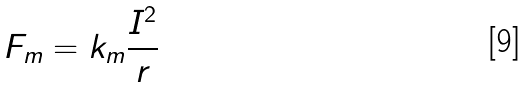Convert formula to latex. <formula><loc_0><loc_0><loc_500><loc_500>F _ { m } = k _ { m } \frac { I ^ { 2 } } { r }</formula> 